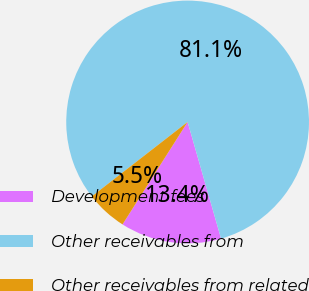<chart> <loc_0><loc_0><loc_500><loc_500><pie_chart><fcel>Development fees<fcel>Other receivables from<fcel>Other receivables from related<nl><fcel>13.45%<fcel>81.07%<fcel>5.48%<nl></chart> 